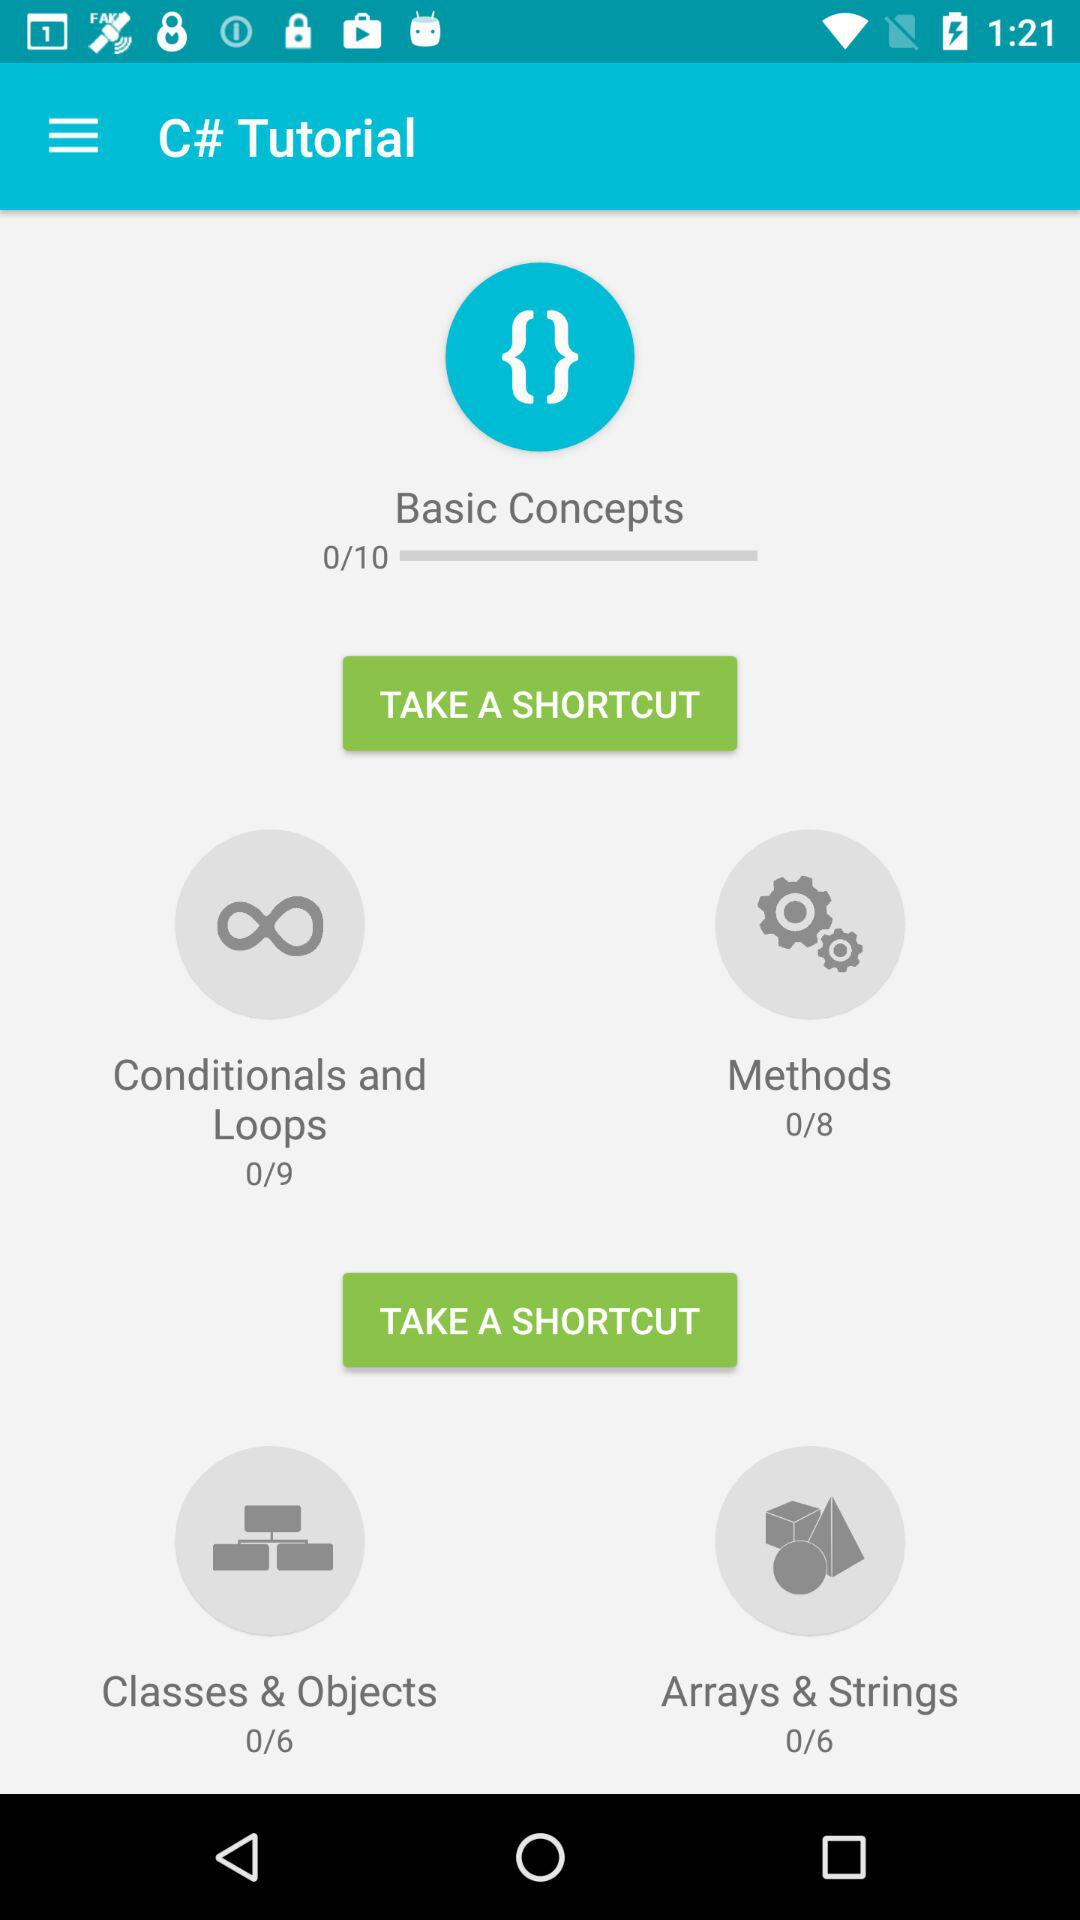How many classes and objects are there in total? There are 6 classes and objects in total. 